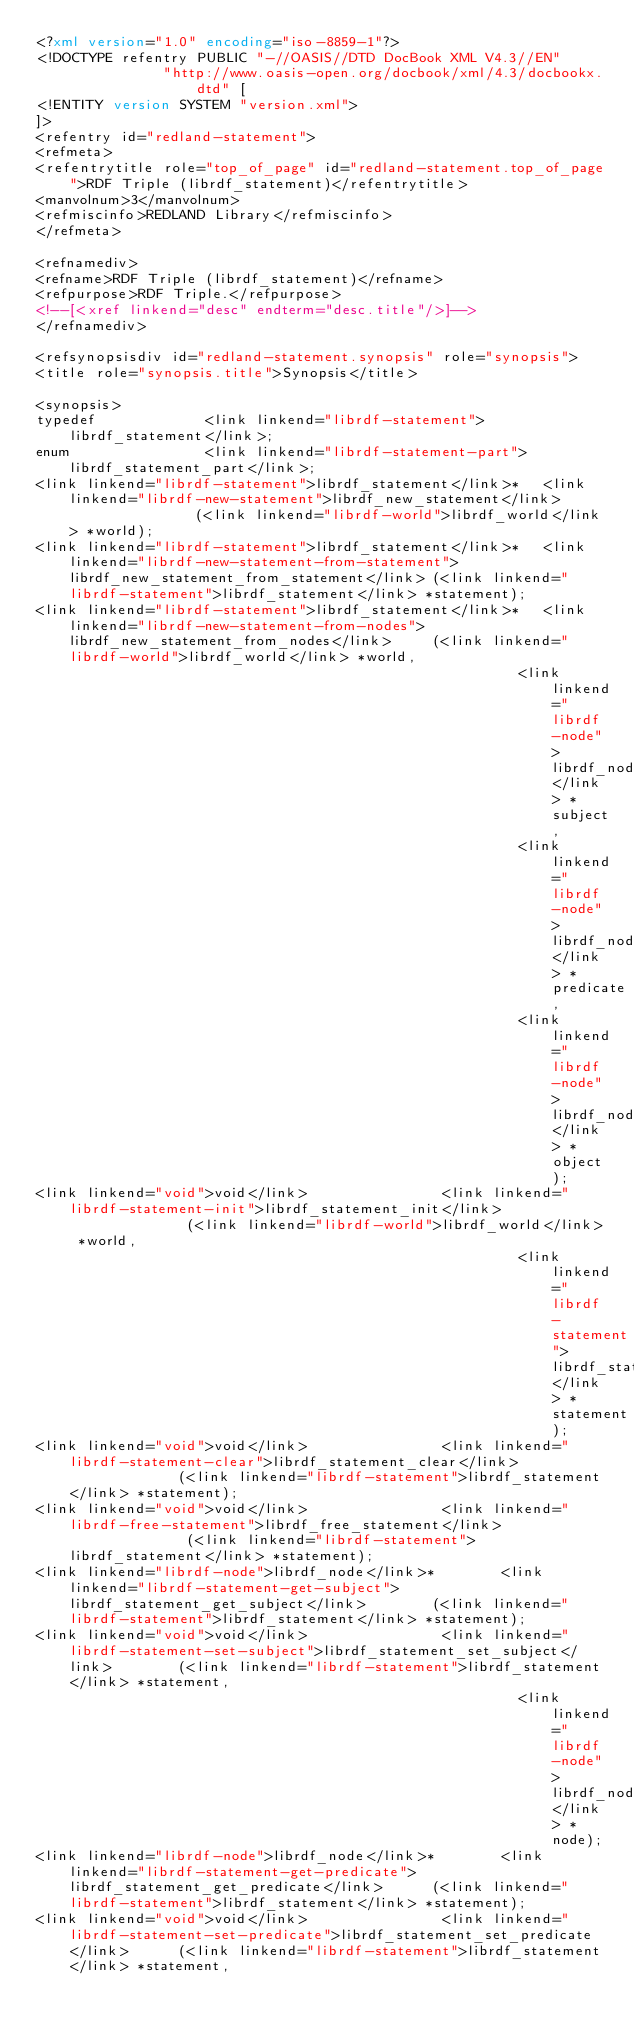<code> <loc_0><loc_0><loc_500><loc_500><_XML_><?xml version="1.0" encoding="iso-8859-1"?>
<!DOCTYPE refentry PUBLIC "-//OASIS//DTD DocBook XML V4.3//EN" 
               "http://www.oasis-open.org/docbook/xml/4.3/docbookx.dtd" [
<!ENTITY version SYSTEM "version.xml">
]>
<refentry id="redland-statement">
<refmeta>
<refentrytitle role="top_of_page" id="redland-statement.top_of_page">RDF Triple (librdf_statement)</refentrytitle>
<manvolnum>3</manvolnum>
<refmiscinfo>REDLAND Library</refmiscinfo>
</refmeta>

<refnamediv>
<refname>RDF Triple (librdf_statement)</refname>
<refpurpose>RDF Triple.</refpurpose>
<!--[<xref linkend="desc" endterm="desc.title"/>]-->
</refnamediv>

<refsynopsisdiv id="redland-statement.synopsis" role="synopsis">
<title role="synopsis.title">Synopsis</title>

<synopsis>
typedef             <link linkend="librdf-statement">librdf_statement</link>;
enum                <link linkend="librdf-statement-part">librdf_statement_part</link>;
<link linkend="librdf-statement">librdf_statement</link>*   <link linkend="librdf-new-statement">librdf_new_statement</link>                (<link linkend="librdf-world">librdf_world</link> *world);
<link linkend="librdf-statement">librdf_statement</link>*   <link linkend="librdf-new-statement-from-statement">librdf_new_statement_from_statement</link> (<link linkend="librdf-statement">librdf_statement</link> *statement);
<link linkend="librdf-statement">librdf_statement</link>*   <link linkend="librdf-new-statement-from-nodes">librdf_new_statement_from_nodes</link>     (<link linkend="librdf-world">librdf_world</link> *world,
                                                         <link linkend="librdf-node">librdf_node</link> *subject,
                                                         <link linkend="librdf-node">librdf_node</link> *predicate,
                                                         <link linkend="librdf-node">librdf_node</link> *object);
<link linkend="void">void</link>                <link linkend="librdf-statement-init">librdf_statement_init</link>               (<link linkend="librdf-world">librdf_world</link> *world,
                                                         <link linkend="librdf-statement">librdf_statement</link> *statement);
<link linkend="void">void</link>                <link linkend="librdf-statement-clear">librdf_statement_clear</link>              (<link linkend="librdf-statement">librdf_statement</link> *statement);
<link linkend="void">void</link>                <link linkend="librdf-free-statement">librdf_free_statement</link>               (<link linkend="librdf-statement">librdf_statement</link> *statement);
<link linkend="librdf-node">librdf_node</link>*        <link linkend="librdf-statement-get-subject">librdf_statement_get_subject</link>        (<link linkend="librdf-statement">librdf_statement</link> *statement);
<link linkend="void">void</link>                <link linkend="librdf-statement-set-subject">librdf_statement_set_subject</link>        (<link linkend="librdf-statement">librdf_statement</link> *statement,
                                                         <link linkend="librdf-node">librdf_node</link> *node);
<link linkend="librdf-node">librdf_node</link>*        <link linkend="librdf-statement-get-predicate">librdf_statement_get_predicate</link>      (<link linkend="librdf-statement">librdf_statement</link> *statement);
<link linkend="void">void</link>                <link linkend="librdf-statement-set-predicate">librdf_statement_set_predicate</link>      (<link linkend="librdf-statement">librdf_statement</link> *statement,</code> 